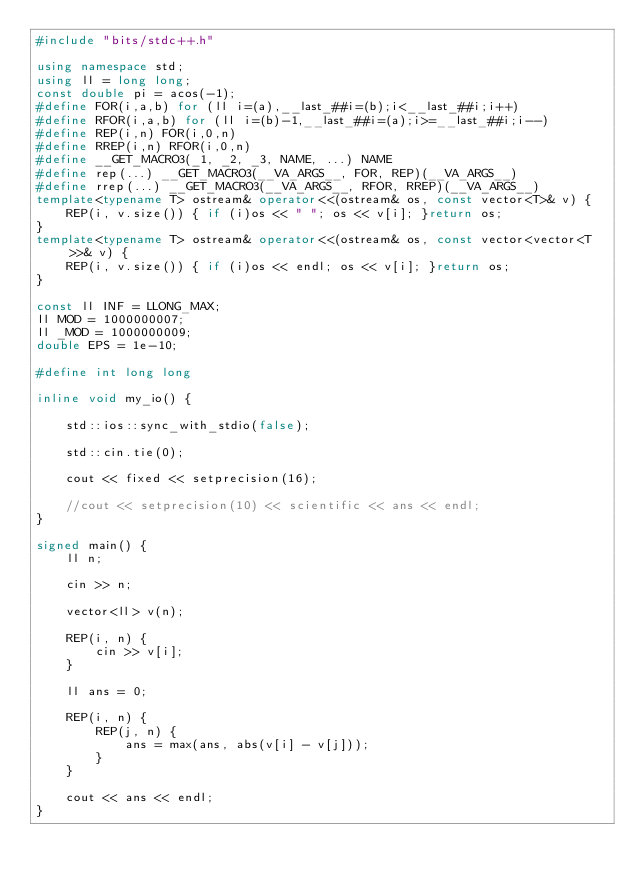Convert code to text. <code><loc_0><loc_0><loc_500><loc_500><_C++_>#include "bits/stdc++.h"

using namespace std;
using ll = long long;
const double pi = acos(-1);
#define FOR(i,a,b) for (ll i=(a),__last_##i=(b);i<__last_##i;i++)
#define RFOR(i,a,b) for (ll i=(b)-1,__last_##i=(a);i>=__last_##i;i--)
#define REP(i,n) FOR(i,0,n)
#define RREP(i,n) RFOR(i,0,n)
#define __GET_MACRO3(_1, _2, _3, NAME, ...) NAME
#define rep(...) __GET_MACRO3(__VA_ARGS__, FOR, REP)(__VA_ARGS__)
#define rrep(...) __GET_MACRO3(__VA_ARGS__, RFOR, RREP)(__VA_ARGS__)
template<typename T> ostream& operator<<(ostream& os, const vector<T>& v) {
	REP(i, v.size()) { if (i)os << " "; os << v[i]; }return os;
}
template<typename T> ostream& operator<<(ostream& os, const vector<vector<T>>& v) {
	REP(i, v.size()) { if (i)os << endl; os << v[i]; }return os;
}

const ll INF = LLONG_MAX;
ll MOD = 1000000007;
ll _MOD = 1000000009;
double EPS = 1e-10;

#define int long long

inline void my_io() {

	std::ios::sync_with_stdio(false);

	std::cin.tie(0);

	cout << fixed << setprecision(16);

	//cout << setprecision(10) << scientific << ans << endl;
}

signed main() {
	ll n;

	cin >> n;

	vector<ll> v(n);

	REP(i, n) {
		cin >> v[i];
	}

	ll ans = 0;

	REP(i, n) {
		REP(j, n) {
			ans = max(ans, abs(v[i] - v[j]));
		}
	}

	cout << ans << endl;
}</code> 